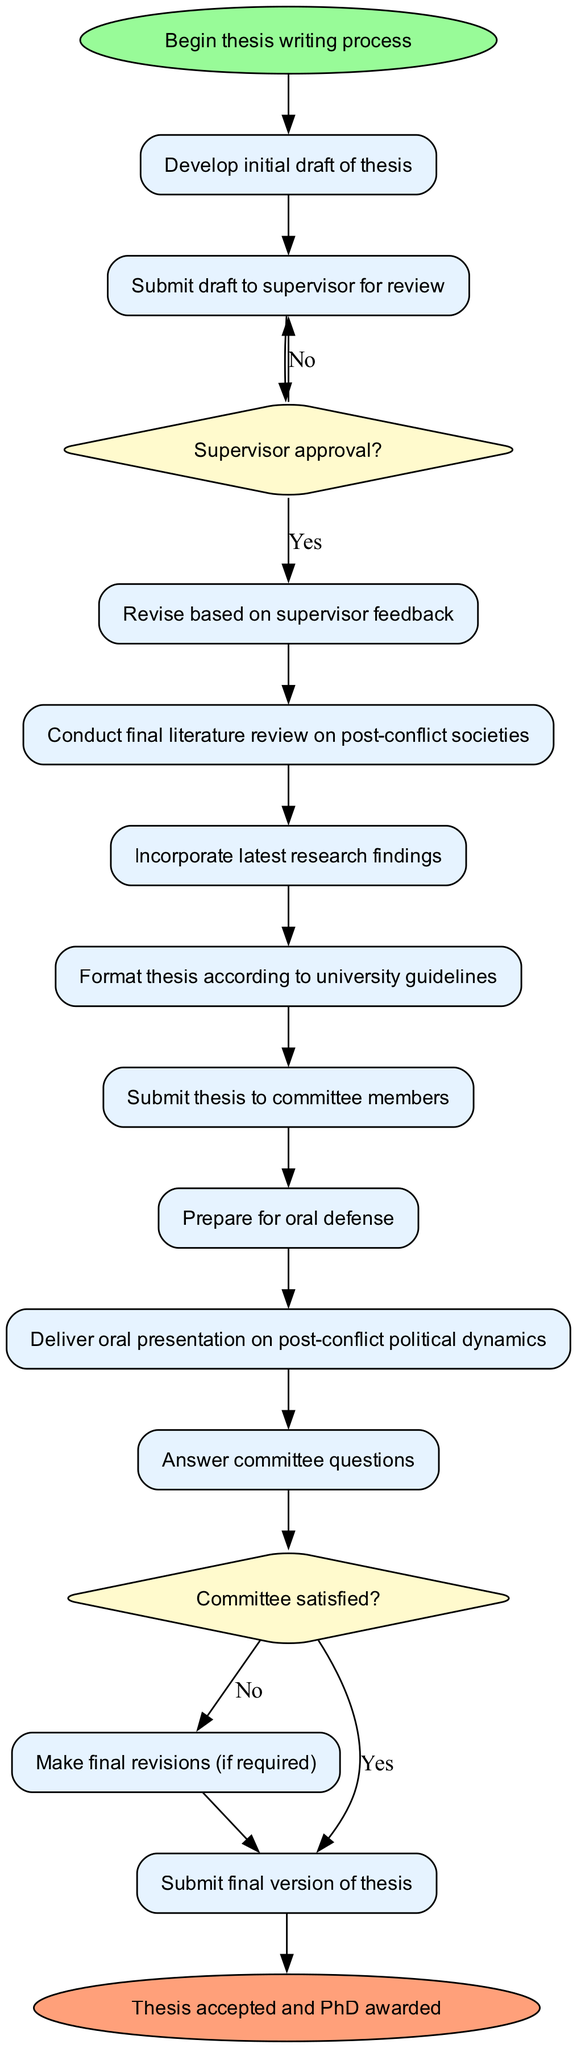What is the first activity in the thesis process? The diagram starts at the 'Begin thesis writing process' node, which leads directly to the first activity, 'Develop initial draft of thesis.'
Answer: Develop initial draft of thesis How many activities are there in total? By counting each activity mentioned in the activities list of the diagram, we see there are twelve listed activities.
Answer: Twelve What happens if the supervisor does not approve the draft? According to the diagram, if the supervisor does not approve the draft (the 'No' branch from 'Supervisor approval?'), it loops back to 'Submit draft to supervisor for review' for further action.
Answer: Submit draft to supervisor for review How many decision nodes are in the diagram? The diagram includes two decision nodes, as indicated in the decisionNodes section.
Answer: Two What must happen after 'Answer committee questions' if the committee is not satisfied? The diagram shows that if the committee is not satisfied (the 'No' branch from 'Committee satisfied?'), the process loops back to 'Make final revisions (if required).'
Answer: Make final revisions (if required) Which node represents the acceptance of the thesis? The end node labeled 'Thesis accepted and PhD awarded' signifies the completion and acceptance of the thesis process.
Answer: Thesis accepted and PhD awarded What is the last activity before submitting the final thesis? The last activity before the final submission, based on the flow of the diagram, is 'Deliver oral presentation on post-conflict political dynamics.'
Answer: Deliver oral presentation on post-conflict political dynamics What is the relationship between 'Submit thesis to committee members' and 'Prepare for oral defense'? The diagram shows a sequential relationship where 'Submit thesis to committee members' directly leads to the next activity 'Prepare for oral defense.'
Answer: Sequential relationship What is the consequence of final revisions? If final revisions are required, it leads to the activity 'Submit final version of thesis,' indicating that revisions are necessary before completing the process.
Answer: Submit final version of thesis 